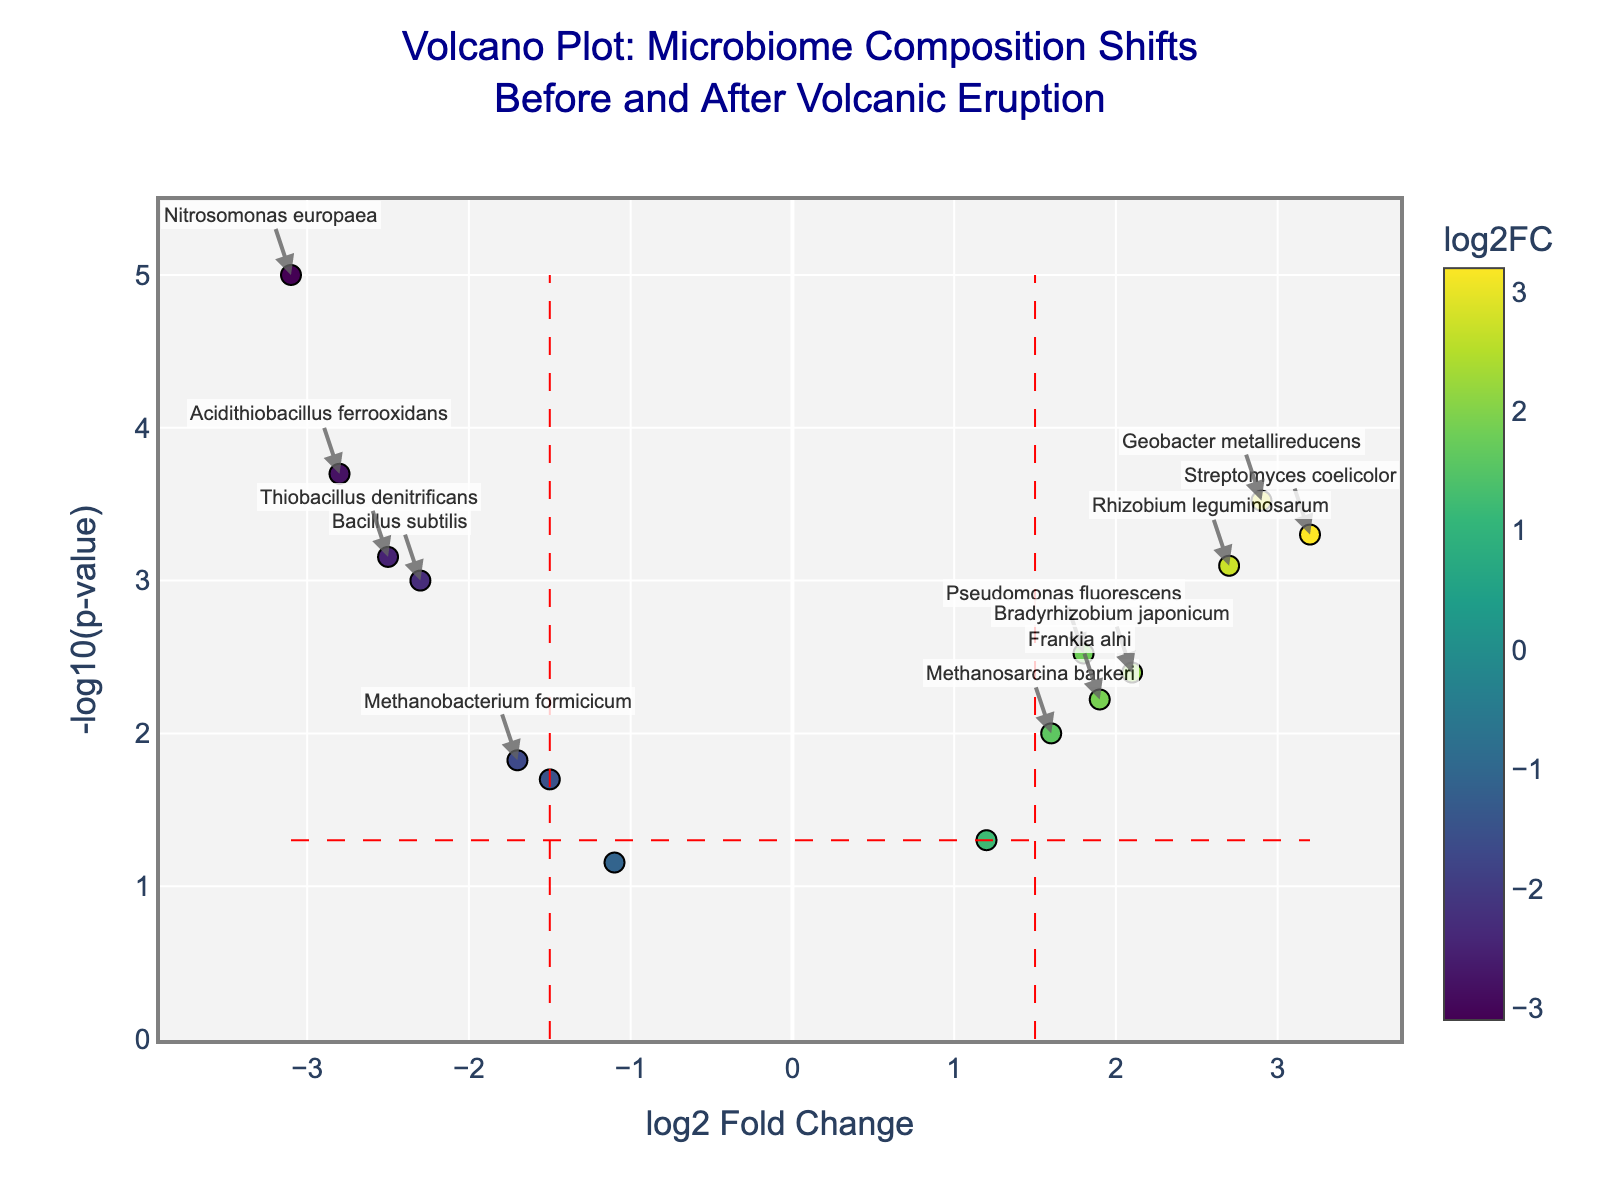How many genes have a log2 fold change above 1.5? Look at the x-axis and identify points with log2 fold change greater than 1.5. There are six such points.
Answer: 6 Which gene has the highest log2 fold change? Find the point furthest to the right on the x-axis. The gene is Streptomyces coelicolor.
Answer: Streptomyces coelicolor Which gene has the smallest p-value? Identify the point highest on the y-axis (since -log10(p-value) is used). The gene is Nitrosomonas europaea.
Answer: Nitrosomonas europaea What is the log2 fold change and p-value of Pseudomonas fluorescens? Locate Pseudomonas fluorescens on the hover text annotation. The values are log2 fold change 1.8 and p-value 0.003.
Answer: log2 fold change 1.8, p-value 0.003 How many genes have significantly increased (above fold change threshold)? Count points to the right of the vertical red line at log2 fold change 1.5 and above the horizontal red line. There are three such points.
Answer: 3 Which genes are significantly decreased after the volcanic eruption? Identify points left of the vertical red line at log2 fold change -1.5 and above the horizontal red line. The genes are Bacillus subtilis, Nitrosomonas europaea, Acidithiobacillus ferrooxidans, and Thiobacillus denitrificans.
Answer: Bacillus subtilis, Nitrosomonas europaea, Acidithiobacillus ferrooxidans, Thiobacillus denitrificans What does the color of each point represent? Note the color bar legend on the side of the plot. It indicates that the color represents the log2 fold change of each gene.
Answer: log2 fold change How many genes have a p-value smaller than 0.05? Count the points above the horizontal red line (-log10(0.05)). There are eleven such points.
Answer: 11 Which gene has the second-highest log2 fold change? Locate the second furthest point to the right on the x-axis. The gene is Geobacter metallireducens.
Answer: Geobacter metallireducens What is the range of the y-axis in the volcano plot? Observe the lowest and highest values on the y-axis (-log10(p-value)). The range is from 0 to approximately 5.
Answer: 0 to 5 